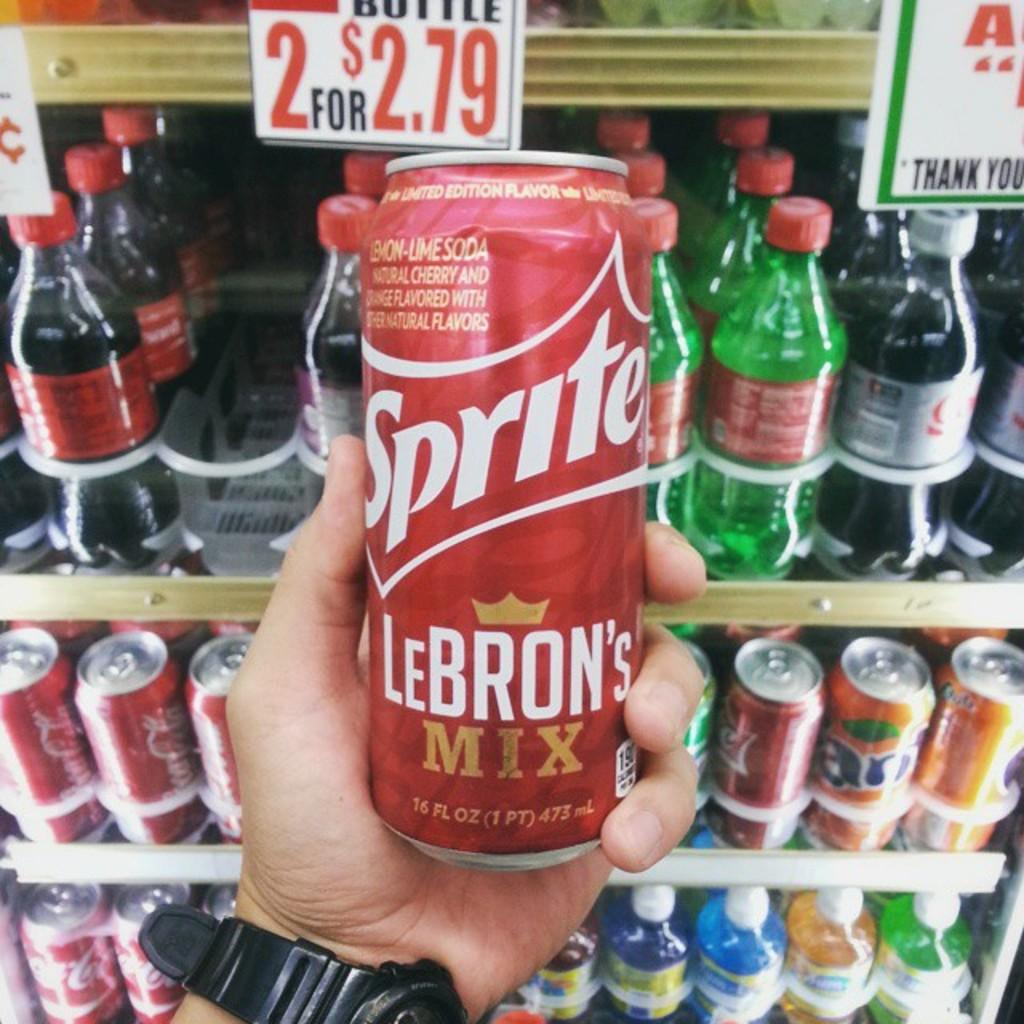<image>
Describe the image concisely. Person's hand holding a sprite can up that says Lebron's mix on it. 